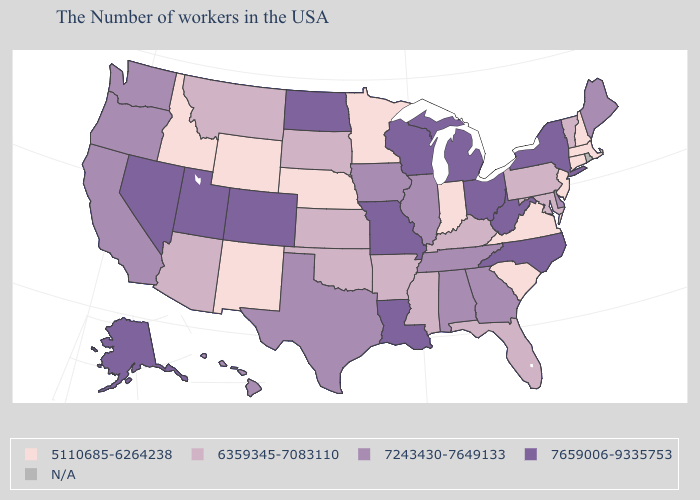Name the states that have a value in the range 7243430-7649133?
Concise answer only. Maine, Delaware, Georgia, Alabama, Tennessee, Illinois, Iowa, Texas, California, Washington, Oregon, Hawaii. Name the states that have a value in the range 5110685-6264238?
Write a very short answer. Massachusetts, New Hampshire, Connecticut, New Jersey, Virginia, South Carolina, Indiana, Minnesota, Nebraska, Wyoming, New Mexico, Idaho. Among the states that border Connecticut , does New York have the highest value?
Give a very brief answer. Yes. Does the first symbol in the legend represent the smallest category?
Concise answer only. Yes. What is the value of Illinois?
Short answer required. 7243430-7649133. Is the legend a continuous bar?
Short answer required. No. What is the value of West Virginia?
Write a very short answer. 7659006-9335753. Name the states that have a value in the range N/A?
Write a very short answer. Rhode Island. Does Massachusetts have the lowest value in the USA?
Write a very short answer. Yes. What is the value of Hawaii?
Keep it brief. 7243430-7649133. Among the states that border Vermont , which have the lowest value?
Give a very brief answer. Massachusetts, New Hampshire. What is the value of Maryland?
Quick response, please. 6359345-7083110. Does California have the highest value in the USA?
Give a very brief answer. No. What is the value of Kentucky?
Short answer required. 6359345-7083110. 